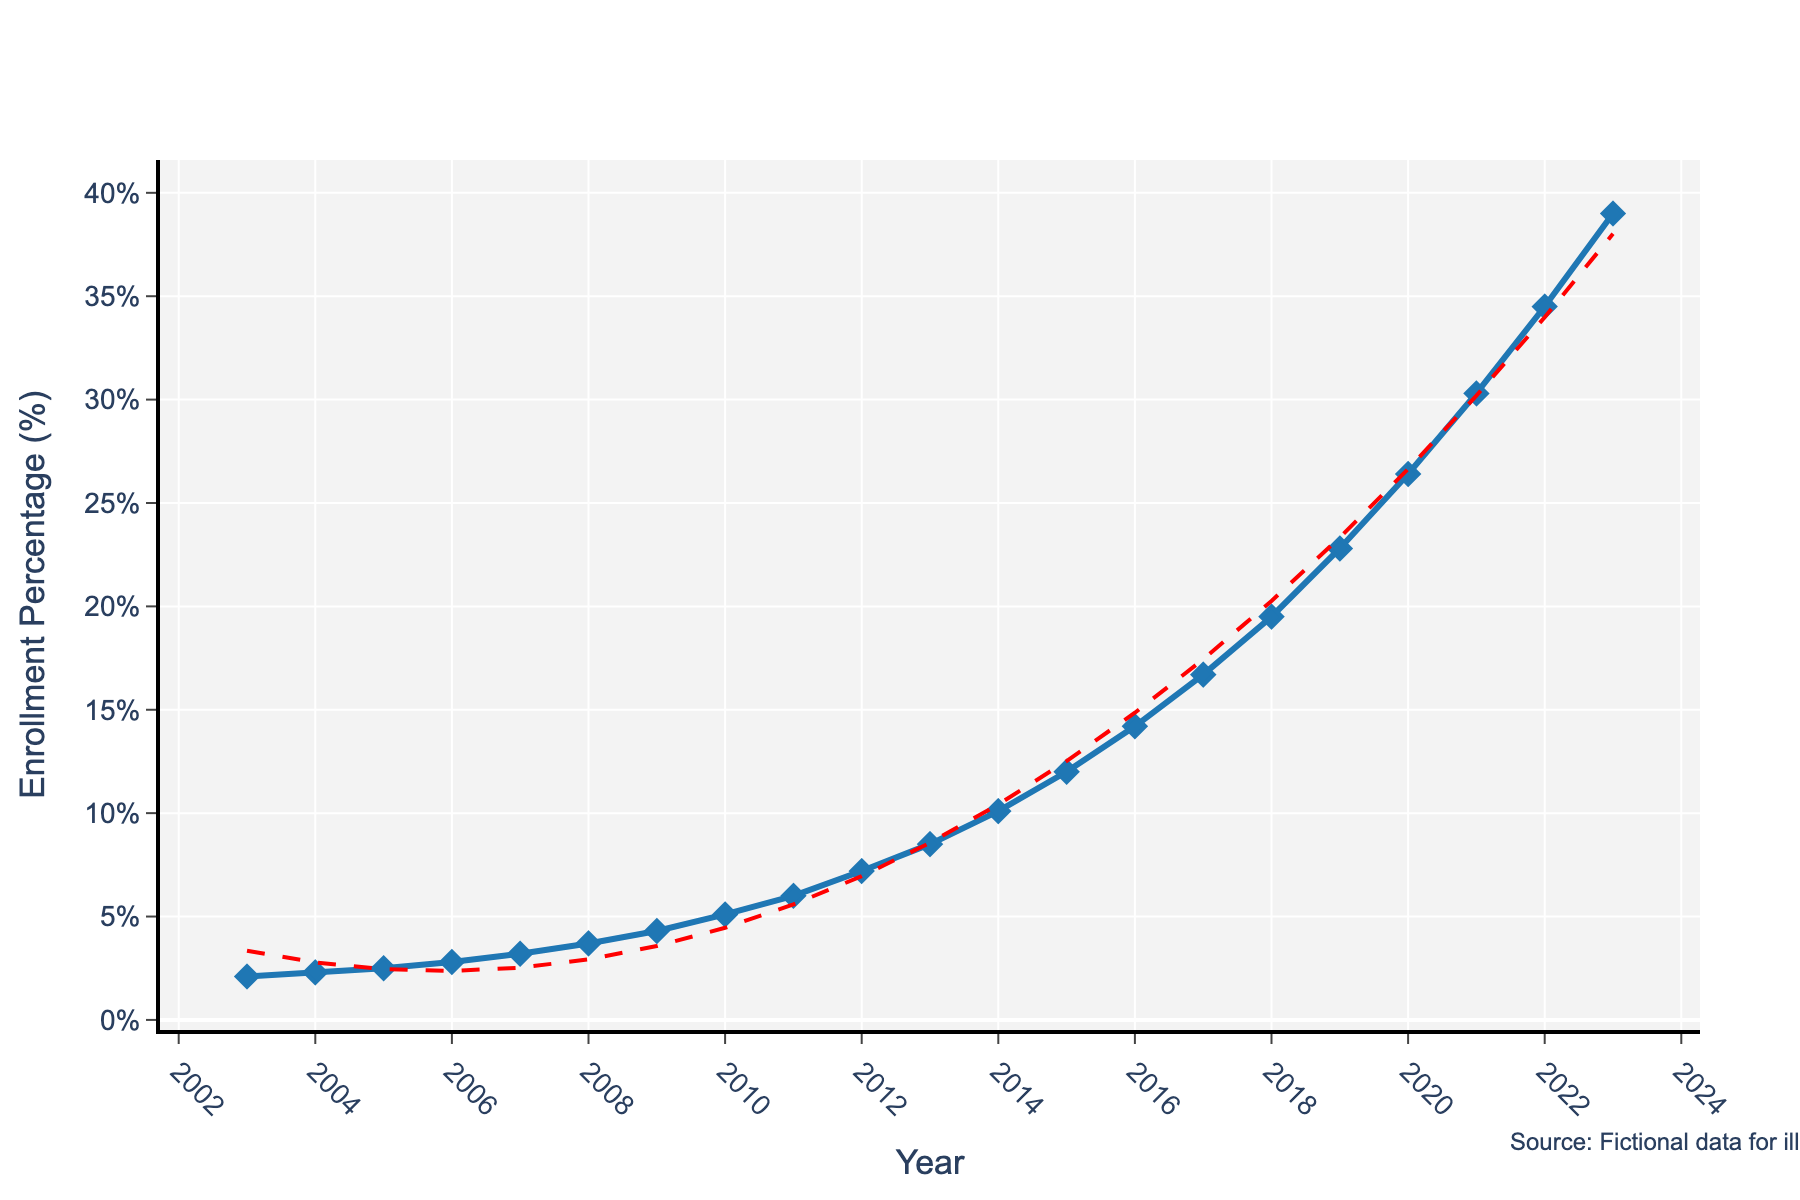What is the trend in the enrollment percentage from 2003 to 2023? To determine the trend in the enrollment percentage, observe the plot from the start year (2003) to the end year (2023). The plot shows a steady increase in the percentage over the years, ending with a significant upward trend.
Answer: An increasing trend What was the enrollment percentage in 2015? Locate the point corresponding to the year 2015 on the x-axis and find its corresponding y-value on the chart. The y-value indicates the enrollment percentage.
Answer: 12.0% What is the difference in enrollment percentages between 2003 and 2023? Identify the enrollment percentages for the years 2003 (2.1%) and 2023 (39.0%). Subtract the enrollment percentage in 2003 from the percentage in 2023 to find the difference.
Answer: 36.9% (39.0% - 2.1%) In which year did the enrollment percentage exceed 10% for the first time? Look for the first point on the plot where the enrollment percentage is just above 10%, tracing it back to the corresponding year on the x-axis.
Answer: 2014 What is the average enrollment percentage for the years between 2010 and 2020 (inclusive)? Identify the enrollment percentages for the years from 2010 to 2020 (5.1%, 6.0%, 7.2%, 8.5%, 10.1%, 12.0%, 14.2%, 16.7%, 19.5%, 22.8%, 26.4%). Sum these percentages and then divide by the number of years (11). Calculation: (5.1 + 6.0 + 7.2 + 8.5 + 10.1 + 12.0 + 14.2 + 16.7 + 19.5 + 22.8 + 26.4) / 11 ≈ 13.6
Answer: 13.6% Between which two consecutive years was the highest increase in enrollment percentage observed? Examine the differences between consecutive years' percentages. The highest difference is between 2022 (34.5%) and 2023 (39.0%), which is 4.5%.
Answer: Between 2022 and 2023 What visual element indicates the overall trend line on the plot? The plot features a secondary line that is red and dashed, representing the trend.
Answer: Red dashed line During which year range did the enrollment growth appear to accelerate most rapidly? Observe the slope of the line; steeper slopes indicate faster growth. The acceleration appears most steep from 2016 onwards, up to 2023.
Answer: 2016-2023 What percentage increase occurred between 2012 and 2013? Identify the enrollment percentages for these two years: 2012 (7.2%) and 2013 (8.5%). The increase is 8.5% - 7.2% = 1.3%.
Answer: 1.3% Was there any year where the enrollment percentage remained the same as the previous year? Check the plot for any flat-run lines between consecutive years, indicating no change in enrollment percentages. The chart shows a steady increase yearly with no years sharing the same percentage.
Answer: No 